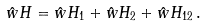<formula> <loc_0><loc_0><loc_500><loc_500>\hat { w } H = \hat { w } H _ { 1 } + \hat { w } H _ { 2 } + \hat { w } H _ { 1 2 } \, .</formula> 